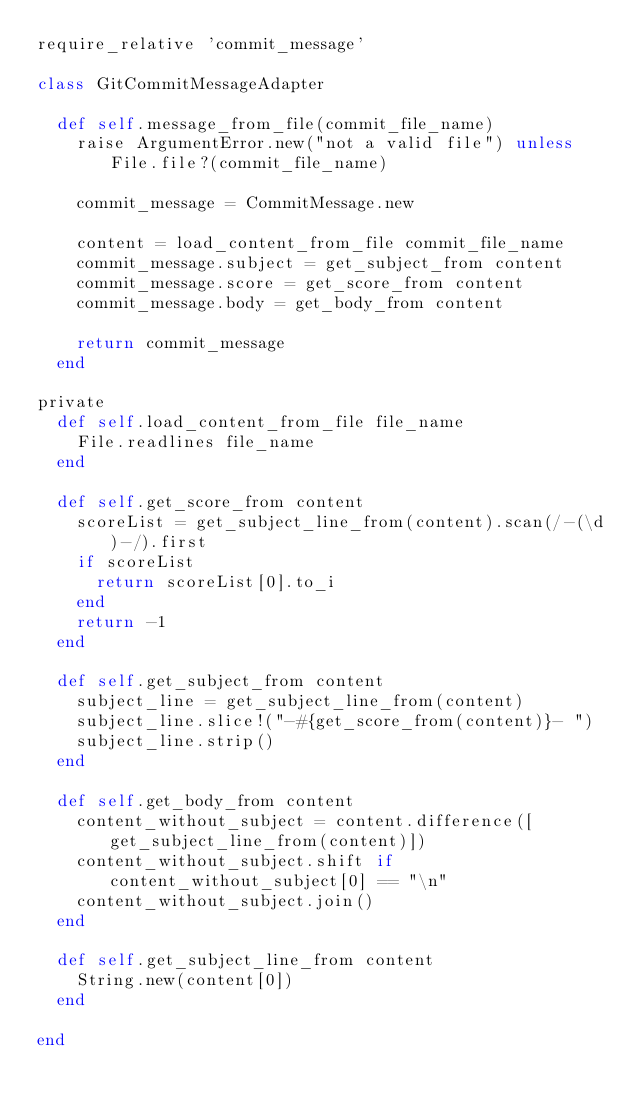Convert code to text. <code><loc_0><loc_0><loc_500><loc_500><_Ruby_>require_relative 'commit_message'

class GitCommitMessageAdapter

  def self.message_from_file(commit_file_name)
    raise ArgumentError.new("not a valid file") unless File.file?(commit_file_name)

    commit_message = CommitMessage.new

    content = load_content_from_file commit_file_name
    commit_message.subject = get_subject_from content
    commit_message.score = get_score_from content
    commit_message.body = get_body_from content

    return commit_message
  end

private
  def self.load_content_from_file file_name
    File.readlines file_name
  end

  def self.get_score_from content
    scoreList = get_subject_line_from(content).scan(/-(\d)-/).first
    if scoreList
      return scoreList[0].to_i
    end
    return -1
  end

  def self.get_subject_from content
    subject_line = get_subject_line_from(content)
    subject_line.slice!("-#{get_score_from(content)}- ")
    subject_line.strip()
  end

  def self.get_body_from content
    content_without_subject = content.difference([get_subject_line_from(content)])
    content_without_subject.shift if content_without_subject[0] == "\n"
    content_without_subject.join()
  end

  def self.get_subject_line_from content
    String.new(content[0])
  end

end
</code> 